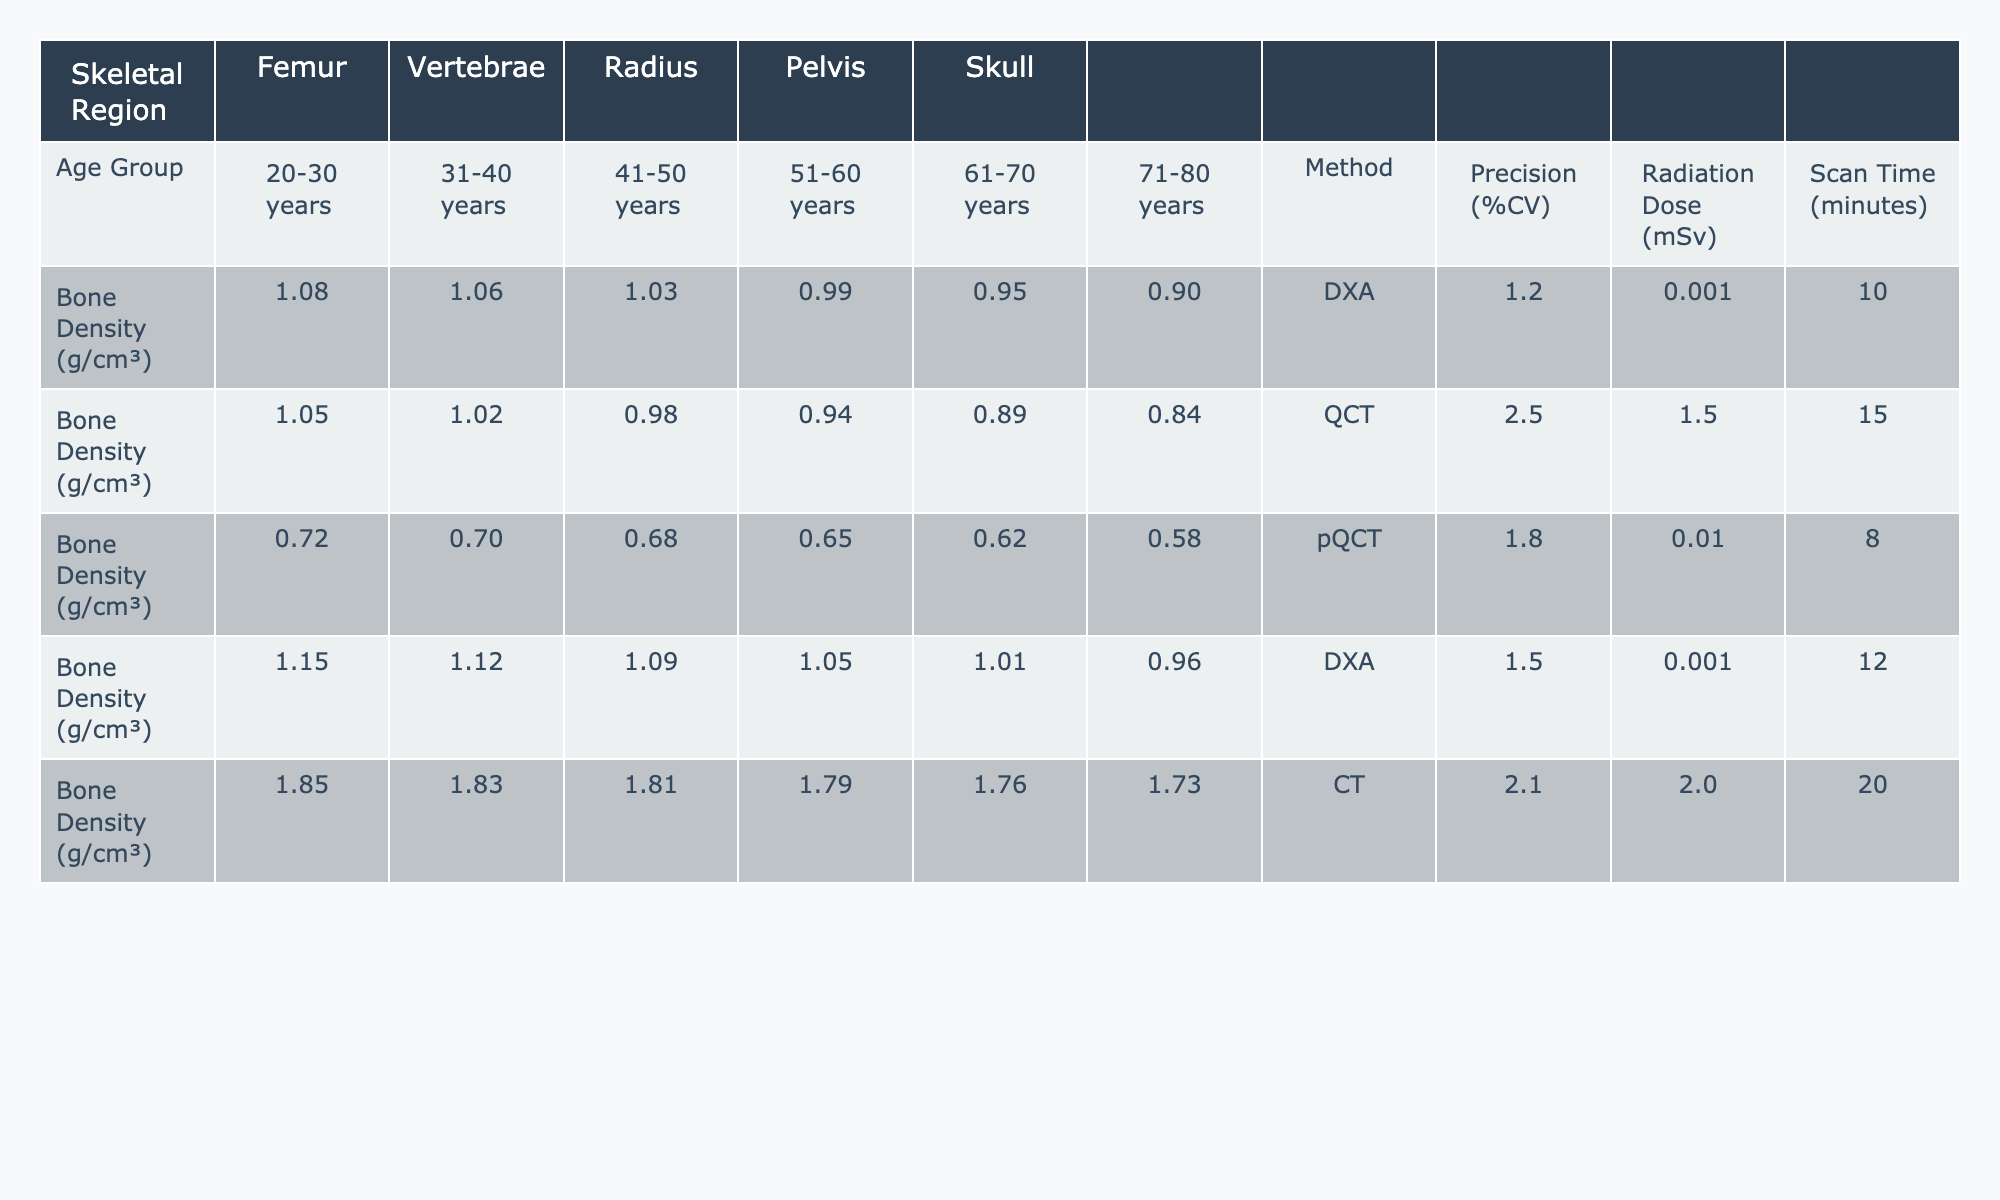What is the bone density of the femur for the age group 41-50 years? In the table, under the column for Femur and the row for the age group 41-50 years, the bone density is listed as 1.03 g/cm³.
Answer: 1.03 g/cm³ Which skeletal region has the highest bone density in the age group 20-30 years? Reviewing the row for the age group 20-30 years, the values under each skeletal region are: Femur (1.08), Vertebrae (1.05), Radius (0.72), Pelvis (1.15), and Skull (1.85). The Skull has the highest value of 1.85 g/cm³.
Answer: Skull What is the average bone density for the pelvis across all age groups? The values for pelvis in the respective age groups are: 1.15, 1.12, 1.09, 1.05, 1.01, and 0.96. Summing these gives (1.15 + 1.12 + 1.09 + 1.05 + 1.01 + 0.96) = 6.38, and dividing by 6 gives an average of 6.38/6 = 1.0633 g/cm³.
Answer: 1.0633 g/cm³ Is the precision of the QCT method greater than that of the DXA method? The precision for QCT is 2.5%, while for DXA it is 1.2%. Since 2.5% is greater than 1.2%, the statement is false.
Answer: No What is the difference in bone density of the skull between the age groups 20-30 years and 71-80 years? In the respective age groups, the bone density for the skull is 1.85 g/cm³ (20-30 years) and 1.73 g/cm³ (71-80 years). The difference can be calculated as 1.85 - 1.73 = 0.12 g/cm³.
Answer: 0.12 g/cm³ Which age group shows the greatest decrease in bone density for the radius? The bone density values for the radius across the age groups are: 0.72 (20-30), 0.70 (31-40), 0.68 (41-50), 0.65 (51-60), 0.62 (61-70), and 0.58 (71-80). The greatest decrease occurs from 0.72 to 0.58, which is a reduction of 0.14 g/cm³ over the age span from 20-30 to 71-80 years.
Answer: 20-30 to 71-80 years What are the radiation doses for the pQCT and CT methods? The radiation dose for the pQCT method is 0.01 mSv, and for the CT method it is 2.0 mSv as indicated in the respective columns under the 'Radiation Dose (mSv)' row.
Answer: pQCT: 0.01 mSv, CT: 2.0 mSv What is the decrease in bone density for the vertebrae from age group 20-30 years to 71-80 years? The values for vertebrae are 1.05 g/cm³ (20-30 years) and 0.84 g/cm³ (71-80 years). The decrease can be calculated as 1.05 - 0.84 = 0.21 g/cm³.
Answer: 0.21 g/cm³ In which skeletal region is the scan time the highest? Looking at the 'Scan Time (minutes)' row, the values are: Femur (10), Vertebrae (15), Radius (8), Pelvis (12), and Skull (20). The highest scan time is 20 minutes for the skull.
Answer: Skull What is the average precision across all measurement methods listed? The precision values are 1.2, 2.5, 1.8, 1.5, and 2.1. Summing these gives (1.2 + 2.5 + 1.8 + 1.5 + 2.1) = 9.1, and dividing by 5 gives an average of 9.1/5 = 1.82%.
Answer: 1.82% 